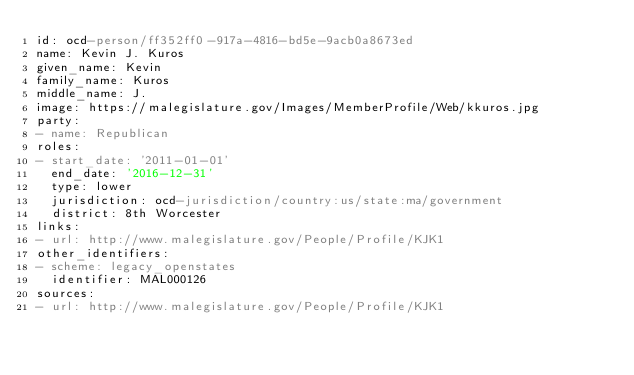Convert code to text. <code><loc_0><loc_0><loc_500><loc_500><_YAML_>id: ocd-person/ff352ff0-917a-4816-bd5e-9acb0a8673ed
name: Kevin J. Kuros
given_name: Kevin
family_name: Kuros
middle_name: J.
image: https://malegislature.gov/Images/MemberProfile/Web/kkuros.jpg
party:
- name: Republican
roles:
- start_date: '2011-01-01'
  end_date: '2016-12-31'
  type: lower
  jurisdiction: ocd-jurisdiction/country:us/state:ma/government
  district: 8th Worcester
links:
- url: http://www.malegislature.gov/People/Profile/KJK1
other_identifiers:
- scheme: legacy_openstates
  identifier: MAL000126
sources:
- url: http://www.malegislature.gov/People/Profile/KJK1
</code> 